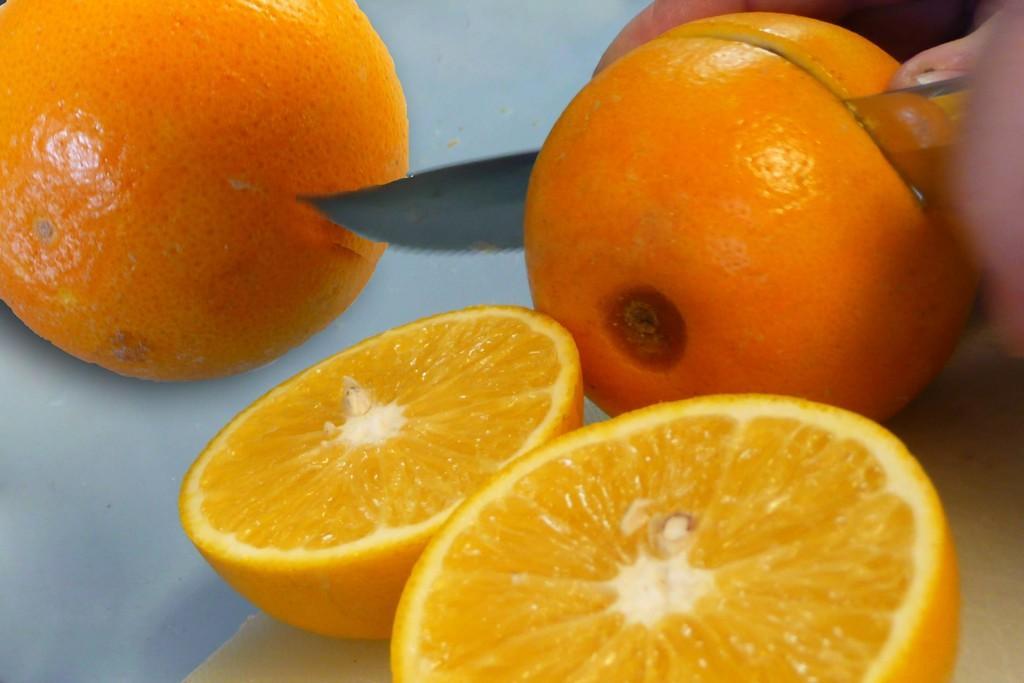Can you describe this image briefly? In this picture we can see oranges and a person holding knife with hand and cutting an orange. 